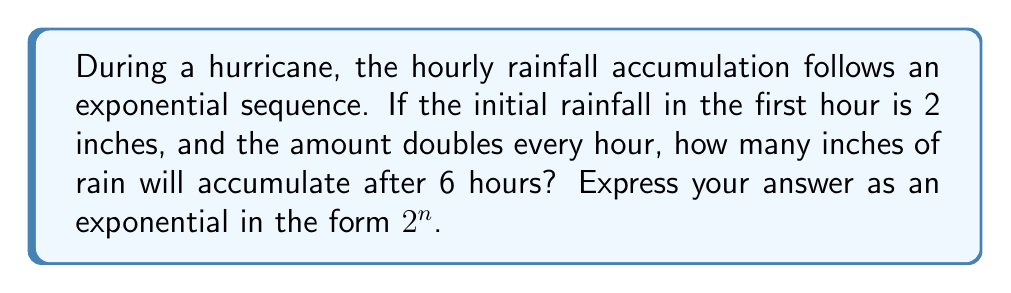Provide a solution to this math problem. Let's approach this step-by-step:

1) The initial rainfall is 2 inches in the first hour.

2) The sequence is exponential, doubling each hour. This can be represented as:

   Hour 1: $2$ inches
   Hour 2: $2 \times 2 = 2^2$ inches
   Hour 3: $2 \times 2 \times 2 = 2^3$ inches
   And so on...

3) To find the total accumulation, we need to sum these values for 6 hours:

   $$ \text{Total} = 2 + 2^2 + 2^3 + 2^4 + 2^5 + 2^6 $$

4) This is a geometric series with first term $a=2$ and common ratio $r=2$.

5) The sum of a geometric series is given by the formula:

   $$ S_n = \frac{a(1-r^n)}{1-r} $$

   where $n$ is the number of terms (6 in this case).

6) Substituting our values:

   $$ S_6 = \frac{2(1-2^6)}{1-2} = \frac{2(1-64)}{-1} = \frac{2(-63)}{-1} = 126 $$

7) We can express this as $2^7 - 2 = 128 - 2 = 126$

Therefore, the total rainfall accumulation after 6 hours is $2^7 - 2$ inches.
Answer: $2^7 - 2$ inches 